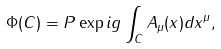<formula> <loc_0><loc_0><loc_500><loc_500>\Phi ( C ) = P \exp i g \int _ { C } A _ { \mu } ( x ) d x ^ { \mu } ,</formula> 